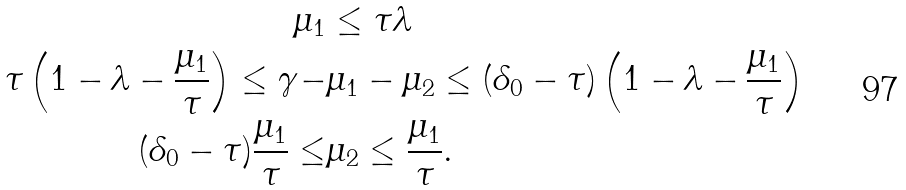<formula> <loc_0><loc_0><loc_500><loc_500>\mu _ { 1 } & \leq \tau \lambda \\ \tau \left ( 1 - \lambda - \frac { \mu _ { 1 } } { \tau } \right ) \leq \gamma - & \mu _ { 1 } - \mu _ { 2 } \leq ( \delta _ { 0 } - \tau ) \left ( 1 - \lambda - \frac { \mu _ { 1 } } { \tau } \right ) \\ ( \delta _ { 0 } - \tau ) \frac { \mu _ { 1 } } { \tau } \leq & \mu _ { 2 } \leq \frac { \mu _ { 1 } } { \tau } .</formula> 